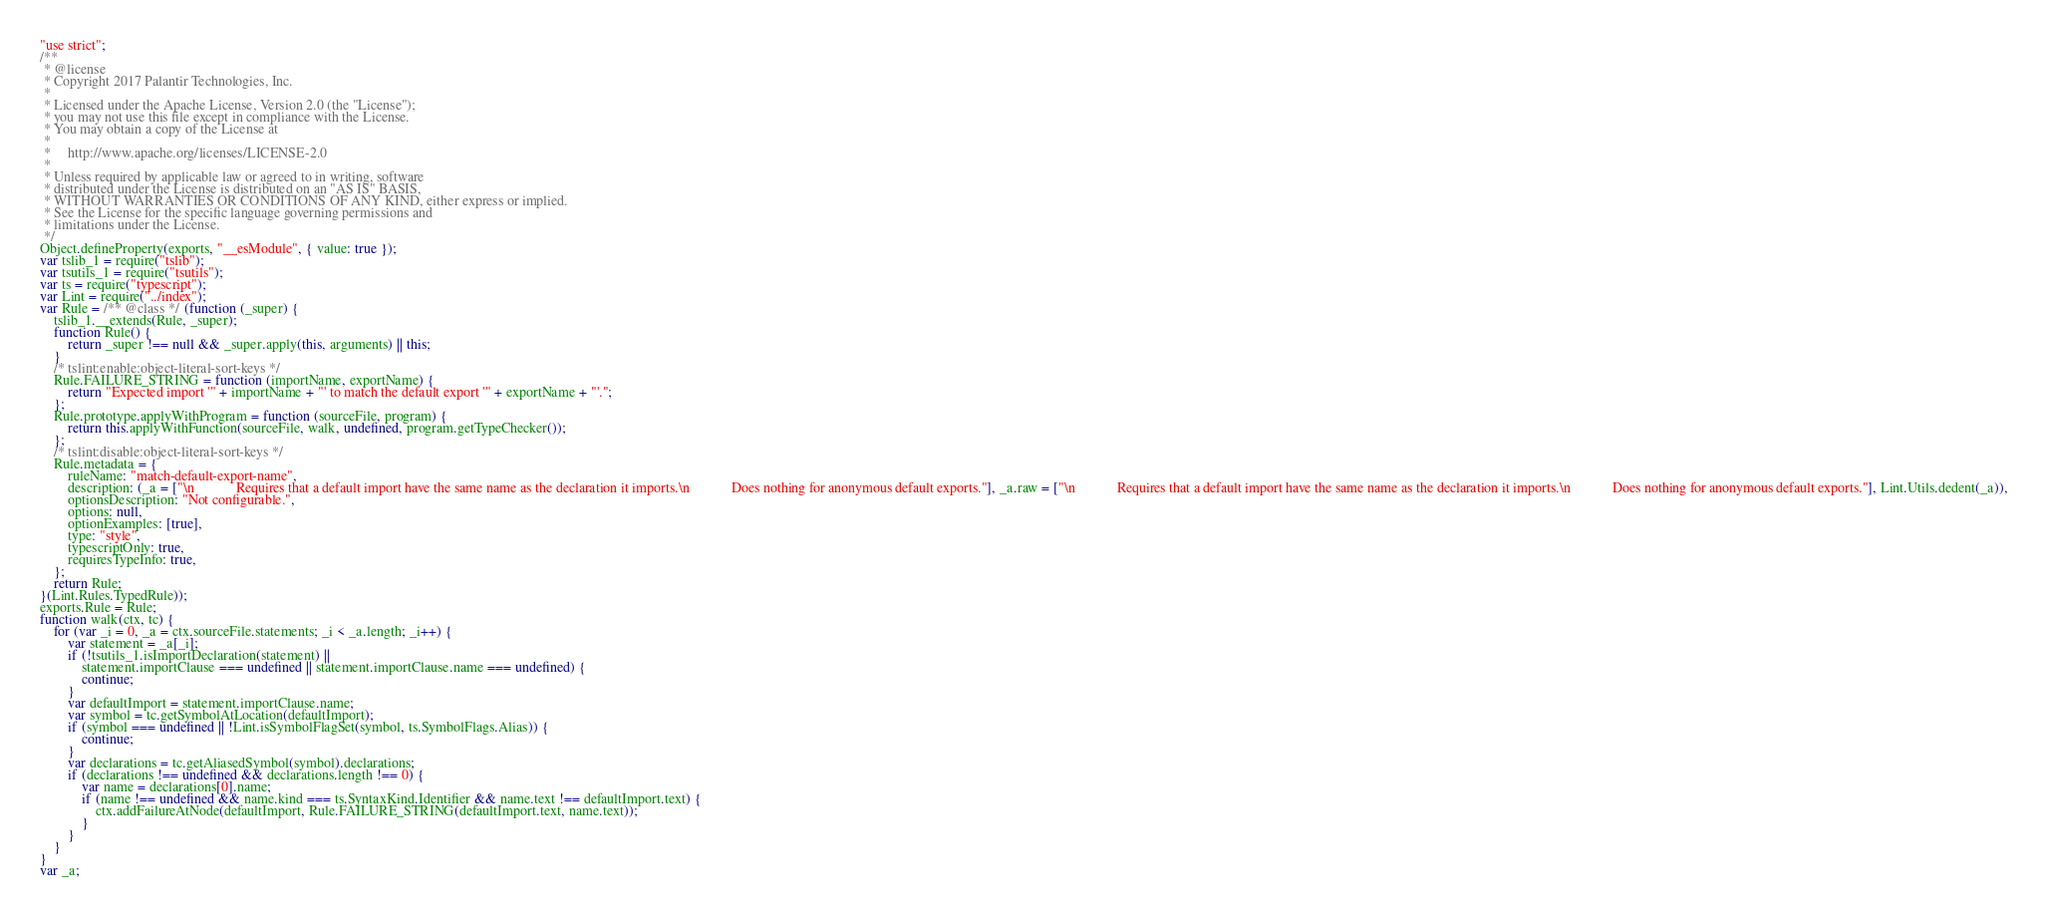Convert code to text. <code><loc_0><loc_0><loc_500><loc_500><_JavaScript_>"use strict";
/**
 * @license
 * Copyright 2017 Palantir Technologies, Inc.
 *
 * Licensed under the Apache License, Version 2.0 (the "License");
 * you may not use this file except in compliance with the License.
 * You may obtain a copy of the License at
 *
 *     http://www.apache.org/licenses/LICENSE-2.0
 *
 * Unless required by applicable law or agreed to in writing, software
 * distributed under the License is distributed on an "AS IS" BASIS,
 * WITHOUT WARRANTIES OR CONDITIONS OF ANY KIND, either express or implied.
 * See the License for the specific language governing permissions and
 * limitations under the License.
 */
Object.defineProperty(exports, "__esModule", { value: true });
var tslib_1 = require("tslib");
var tsutils_1 = require("tsutils");
var ts = require("typescript");
var Lint = require("../index");
var Rule = /** @class */ (function (_super) {
    tslib_1.__extends(Rule, _super);
    function Rule() {
        return _super !== null && _super.apply(this, arguments) || this;
    }
    /* tslint:enable:object-literal-sort-keys */
    Rule.FAILURE_STRING = function (importName, exportName) {
        return "Expected import '" + importName + "' to match the default export '" + exportName + "'.";
    };
    Rule.prototype.applyWithProgram = function (sourceFile, program) {
        return this.applyWithFunction(sourceFile, walk, undefined, program.getTypeChecker());
    };
    /* tslint:disable:object-literal-sort-keys */
    Rule.metadata = {
        ruleName: "match-default-export-name",
        description: (_a = ["\n            Requires that a default import have the same name as the declaration it imports.\n            Does nothing for anonymous default exports."], _a.raw = ["\n            Requires that a default import have the same name as the declaration it imports.\n            Does nothing for anonymous default exports."], Lint.Utils.dedent(_a)),
        optionsDescription: "Not configurable.",
        options: null,
        optionExamples: [true],
        type: "style",
        typescriptOnly: true,
        requiresTypeInfo: true,
    };
    return Rule;
}(Lint.Rules.TypedRule));
exports.Rule = Rule;
function walk(ctx, tc) {
    for (var _i = 0, _a = ctx.sourceFile.statements; _i < _a.length; _i++) {
        var statement = _a[_i];
        if (!tsutils_1.isImportDeclaration(statement) ||
            statement.importClause === undefined || statement.importClause.name === undefined) {
            continue;
        }
        var defaultImport = statement.importClause.name;
        var symbol = tc.getSymbolAtLocation(defaultImport);
        if (symbol === undefined || !Lint.isSymbolFlagSet(symbol, ts.SymbolFlags.Alias)) {
            continue;
        }
        var declarations = tc.getAliasedSymbol(symbol).declarations;
        if (declarations !== undefined && declarations.length !== 0) {
            var name = declarations[0].name;
            if (name !== undefined && name.kind === ts.SyntaxKind.Identifier && name.text !== defaultImport.text) {
                ctx.addFailureAtNode(defaultImport, Rule.FAILURE_STRING(defaultImport.text, name.text));
            }
        }
    }
}
var _a;
</code> 